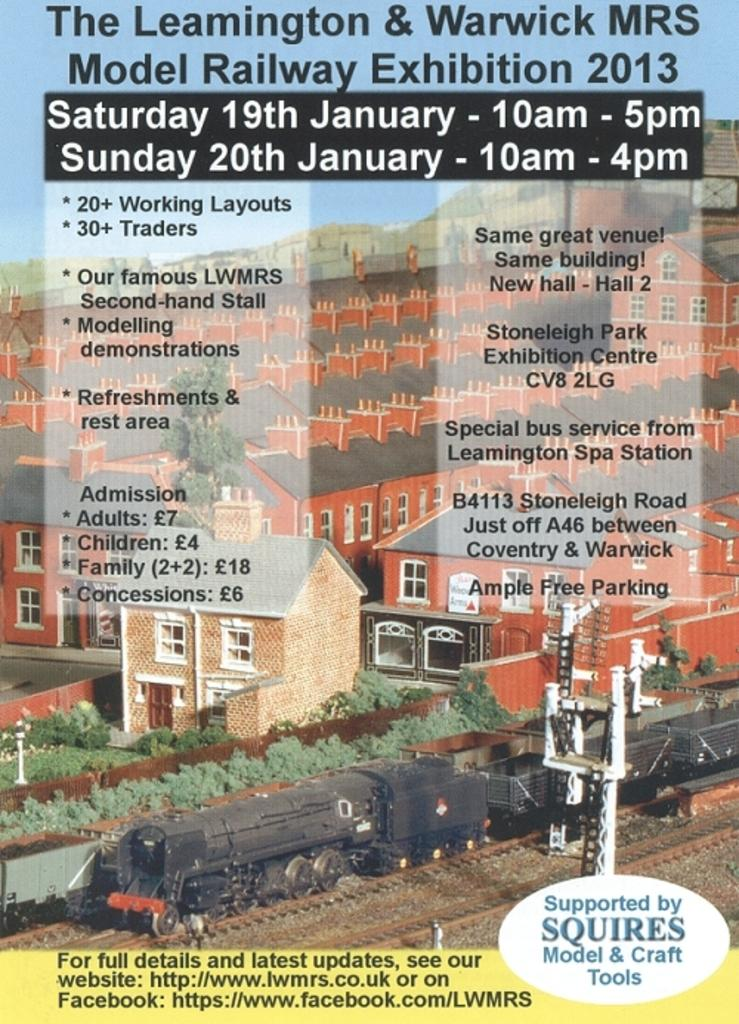<image>
Summarize the visual content of the image. an advertisement for a 2013 model railway exhibit  has all of the activites listed 